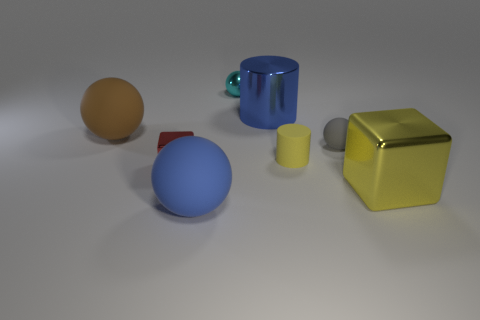Is there a big blue thing that has the same shape as the small yellow object?
Ensure brevity in your answer.  Yes. There is a cyan thing; what shape is it?
Provide a succinct answer. Sphere. What number of objects are cubes or big blue metal cubes?
Make the answer very short. 2. There is a metal cube on the left side of the blue metal cylinder; is its size the same as the sphere right of the big blue shiny cylinder?
Offer a very short reply. Yes. What number of other objects are the same material as the tiny yellow object?
Your answer should be very brief. 3. Is the number of small red shiny cubes that are on the right side of the big brown matte object greater than the number of blue matte objects that are in front of the yellow cylinder?
Make the answer very short. No. What is the cylinder that is behind the small matte cylinder made of?
Provide a succinct answer. Metal. Does the blue shiny object have the same shape as the small cyan thing?
Your answer should be compact. No. Is there any other thing that is the same color as the matte cylinder?
Give a very brief answer. Yes. What color is the other small metal thing that is the same shape as the gray object?
Give a very brief answer. Cyan. 